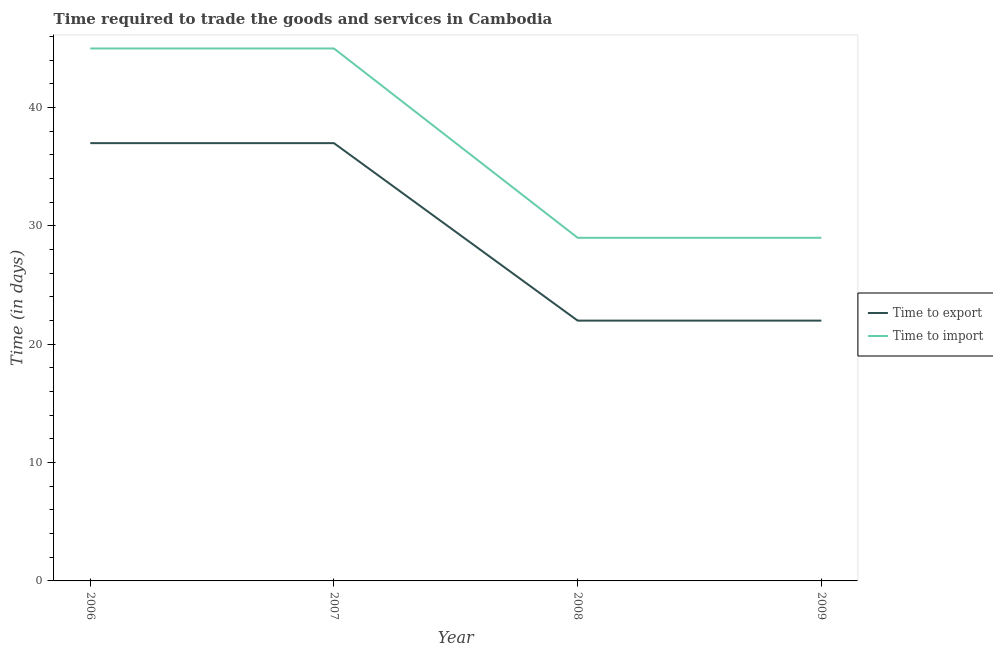What is the time to export in 2007?
Ensure brevity in your answer.  37. Across all years, what is the maximum time to export?
Offer a terse response. 37. Across all years, what is the minimum time to import?
Your answer should be compact. 29. In which year was the time to import maximum?
Ensure brevity in your answer.  2006. What is the total time to export in the graph?
Offer a very short reply. 118. What is the difference between the time to export in 2006 and that in 2009?
Provide a short and direct response. 15. What is the difference between the time to import in 2007 and the time to export in 2009?
Ensure brevity in your answer.  23. What is the average time to import per year?
Provide a succinct answer. 37. In the year 2008, what is the difference between the time to export and time to import?
Provide a short and direct response. -7. In how many years, is the time to export greater than 4 days?
Offer a terse response. 4. What is the ratio of the time to import in 2007 to that in 2008?
Your response must be concise. 1.55. What is the difference between the highest and the second highest time to export?
Your response must be concise. 0. What is the difference between the highest and the lowest time to import?
Your answer should be very brief. 16. Does the time to import monotonically increase over the years?
Your response must be concise. No. How many lines are there?
Your response must be concise. 2. How many years are there in the graph?
Offer a very short reply. 4. Does the graph contain grids?
Keep it short and to the point. No. How many legend labels are there?
Your answer should be very brief. 2. How are the legend labels stacked?
Offer a very short reply. Vertical. What is the title of the graph?
Give a very brief answer. Time required to trade the goods and services in Cambodia. Does "Secondary Education" appear as one of the legend labels in the graph?
Your response must be concise. No. What is the label or title of the Y-axis?
Offer a terse response. Time (in days). What is the Time (in days) in Time to import in 2006?
Offer a terse response. 45. What is the Time (in days) in Time to import in 2008?
Your answer should be compact. 29. What is the Time (in days) in Time to import in 2009?
Provide a short and direct response. 29. Across all years, what is the maximum Time (in days) of Time to import?
Keep it short and to the point. 45. Across all years, what is the minimum Time (in days) of Time to export?
Provide a succinct answer. 22. What is the total Time (in days) of Time to export in the graph?
Offer a terse response. 118. What is the total Time (in days) of Time to import in the graph?
Your answer should be very brief. 148. What is the difference between the Time (in days) of Time to export in 2006 and that in 2007?
Offer a very short reply. 0. What is the difference between the Time (in days) in Time to import in 2006 and that in 2007?
Your response must be concise. 0. What is the difference between the Time (in days) of Time to export in 2006 and that in 2008?
Keep it short and to the point. 15. What is the difference between the Time (in days) of Time to export in 2007 and that in 2008?
Provide a succinct answer. 15. What is the difference between the Time (in days) of Time to import in 2007 and that in 2009?
Your answer should be very brief. 16. What is the difference between the Time (in days) in Time to import in 2008 and that in 2009?
Offer a very short reply. 0. What is the difference between the Time (in days) in Time to export in 2006 and the Time (in days) in Time to import in 2008?
Your answer should be very brief. 8. What is the difference between the Time (in days) in Time to export in 2007 and the Time (in days) in Time to import in 2008?
Ensure brevity in your answer.  8. What is the average Time (in days) of Time to export per year?
Give a very brief answer. 29.5. In the year 2006, what is the difference between the Time (in days) in Time to export and Time (in days) in Time to import?
Make the answer very short. -8. In the year 2007, what is the difference between the Time (in days) of Time to export and Time (in days) of Time to import?
Offer a terse response. -8. What is the ratio of the Time (in days) in Time to export in 2006 to that in 2007?
Make the answer very short. 1. What is the ratio of the Time (in days) in Time to export in 2006 to that in 2008?
Ensure brevity in your answer.  1.68. What is the ratio of the Time (in days) in Time to import in 2006 to that in 2008?
Provide a short and direct response. 1.55. What is the ratio of the Time (in days) of Time to export in 2006 to that in 2009?
Provide a succinct answer. 1.68. What is the ratio of the Time (in days) in Time to import in 2006 to that in 2009?
Ensure brevity in your answer.  1.55. What is the ratio of the Time (in days) in Time to export in 2007 to that in 2008?
Offer a terse response. 1.68. What is the ratio of the Time (in days) in Time to import in 2007 to that in 2008?
Provide a succinct answer. 1.55. What is the ratio of the Time (in days) of Time to export in 2007 to that in 2009?
Offer a terse response. 1.68. What is the ratio of the Time (in days) of Time to import in 2007 to that in 2009?
Ensure brevity in your answer.  1.55. What is the ratio of the Time (in days) in Time to export in 2008 to that in 2009?
Ensure brevity in your answer.  1. 